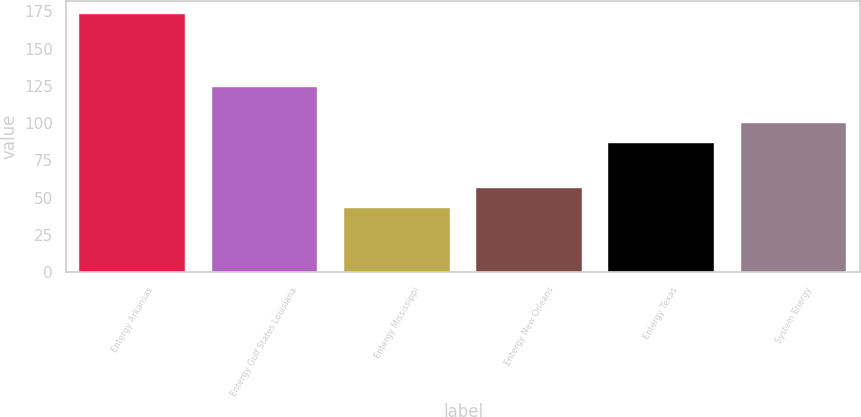Convert chart to OTSL. <chart><loc_0><loc_0><loc_500><loc_500><bar_chart><fcel>Entergy Arkansas<fcel>Entergy Gulf States Louisiana<fcel>Entergy Mississippi<fcel>Entergy New Orleans<fcel>Entergy Texas<fcel>System Energy<nl><fcel>173.4<fcel>124.3<fcel>43.4<fcel>56.4<fcel>86.4<fcel>100.2<nl></chart> 